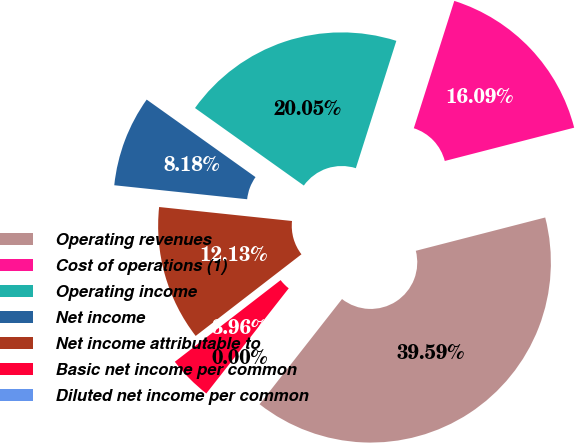Convert chart to OTSL. <chart><loc_0><loc_0><loc_500><loc_500><pie_chart><fcel>Operating revenues<fcel>Cost of operations (1)<fcel>Operating income<fcel>Net income<fcel>Net income attributable to<fcel>Basic net income per common<fcel>Diluted net income per common<nl><fcel>39.59%<fcel>16.09%<fcel>20.05%<fcel>8.18%<fcel>12.13%<fcel>3.96%<fcel>0.0%<nl></chart> 